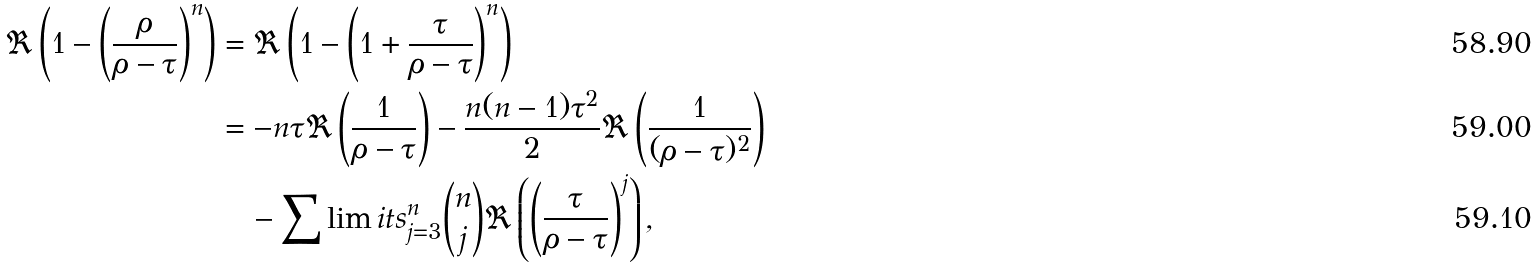Convert formula to latex. <formula><loc_0><loc_0><loc_500><loc_500>\Re \left ( 1 - \left ( \frac { \rho } { \rho - \tau } \right ) ^ { n } \right ) & = \Re \left ( 1 - \left ( 1 + \frac { \tau } { \rho - \tau } \right ) ^ { n } \right ) \\ & = - n \tau \Re \left ( \frac { 1 } { \rho - \tau } \right ) - \frac { n ( n - 1 ) \tau ^ { 2 } } { 2 } \Re \left ( \frac { 1 } { ( \rho - \tau ) ^ { 2 } } \right ) \\ & \quad - \sum \lim i t s _ { j = 3 } ^ { n } \binom { n } { j } \Re \left ( \left ( \frac { \tau } { \rho - \tau } \right ) ^ { j } \right ) ,</formula> 